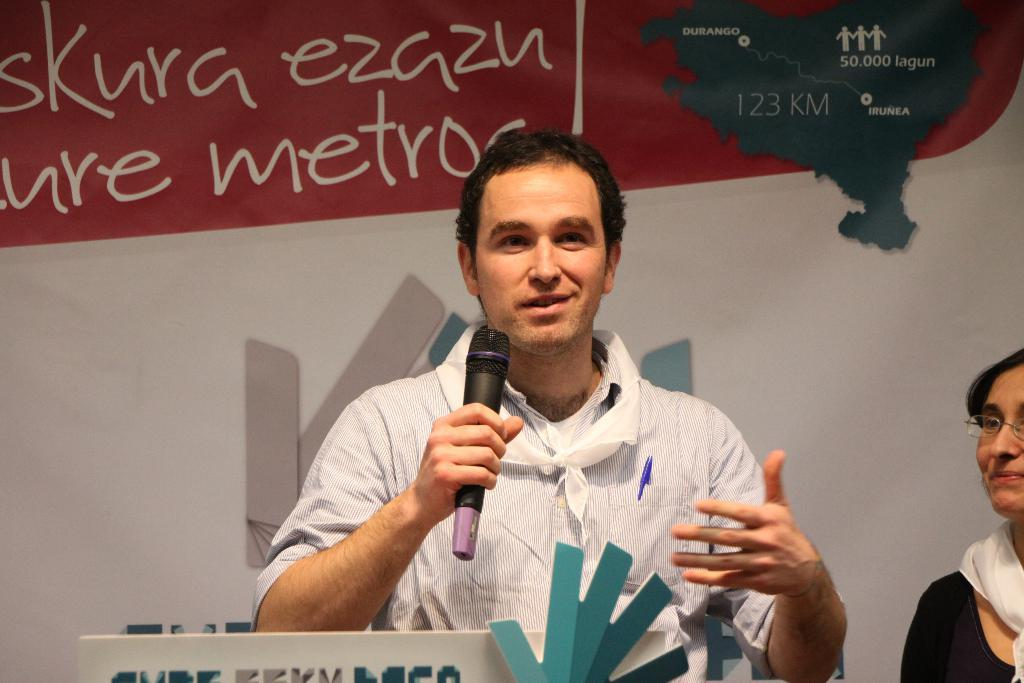What is the man in the image holding? The man is holding a mic with his hand. What is the man's facial expression in the image? The man is smiling. What object can be seen in the image besides the mic? There is a pen in the image. Can you describe the woman in the image? The woman is wearing spectacles. What is visible in the background of the image? There is a banner in the background of the image. What type of stamp can be seen on the man's forehead in the image? There is no stamp visible on the man's forehead in the image. 